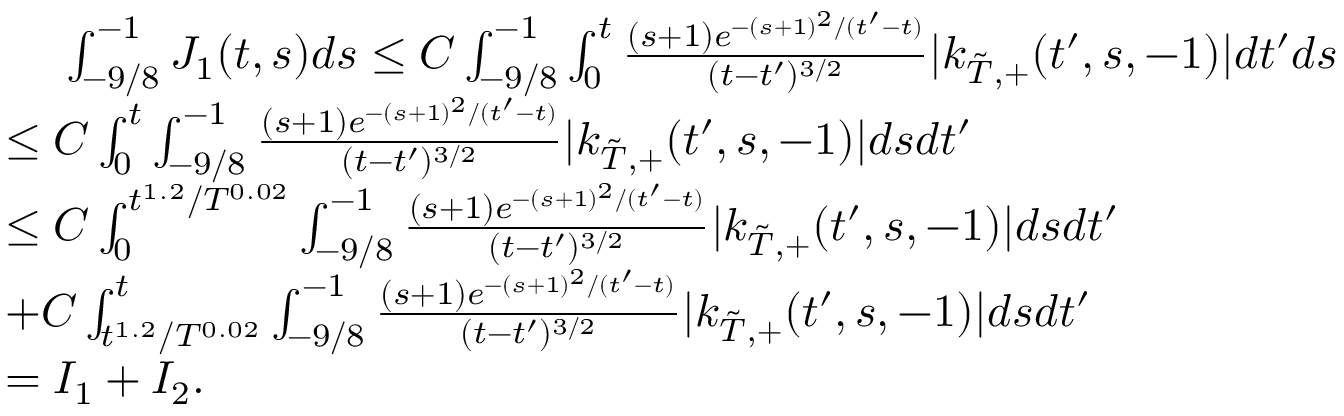<formula> <loc_0><loc_0><loc_500><loc_500>\begin{array} { r l } & { \quad \int _ { - 9 / 8 } ^ { - 1 } J _ { 1 } ( t , s ) d s \leq C \int _ { - 9 / 8 } ^ { - 1 } \int _ { 0 } ^ { t } \frac { ( s + 1 ) e ^ { - ( s + 1 ) ^ { 2 } / ( t ^ { \prime } - t ) } } { ( t - t ^ { \prime } ) ^ { 3 / 2 } } | k _ { { \tilde { T } } , + } ( t ^ { \prime } , s , - 1 ) | d t ^ { \prime } d s } \\ & { \leq C \int _ { 0 } ^ { t } \int _ { - 9 / 8 } ^ { - 1 } \frac { ( s + 1 ) e ^ { - ( s + 1 ) ^ { 2 } / ( t ^ { \prime } - t ) } } { ( t - t ^ { \prime } ) ^ { 3 / 2 } } | k _ { { \tilde { T } } , + } ( t ^ { \prime } , s , - 1 ) | d s d t ^ { \prime } } \\ & { \leq C \int _ { 0 } ^ { t ^ { 1 . 2 } / T ^ { 0 . 0 2 } } \int _ { - 9 / 8 } ^ { - 1 } \frac { ( s + 1 ) e ^ { - ( s + 1 ) ^ { 2 } / ( t ^ { \prime } - t ) } } { ( t - t ^ { \prime } ) ^ { 3 / 2 } } | k _ { { \tilde { T } } , + } ( t ^ { \prime } , s , - 1 ) | d s d t ^ { \prime } } \\ & { + C \int _ { t ^ { 1 . 2 } / T ^ { 0 . 0 2 } } ^ { t } \int _ { - 9 / 8 } ^ { - 1 } \frac { ( s + 1 ) e ^ { - ( s + 1 ) ^ { 2 } / ( t ^ { \prime } - t ) } } { ( t - t ^ { \prime } ) ^ { 3 / 2 } } | k _ { { \tilde { T } } , + } ( t ^ { \prime } , s , - 1 ) | d s d t ^ { \prime } } \\ & { = I _ { 1 } + I _ { 2 } . } \end{array}</formula> 